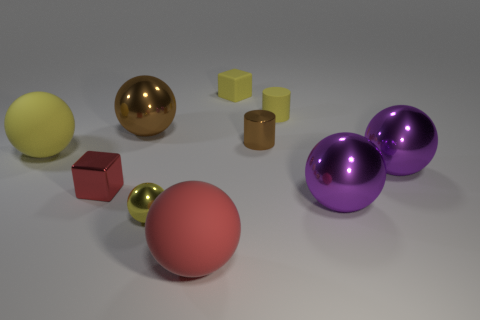Are there an equal number of purple metallic things that are left of the big red rubber thing and matte blocks?
Give a very brief answer. No. There is a matte sphere to the right of the large brown metallic sphere; what size is it?
Offer a terse response. Large. What number of yellow things are the same shape as the tiny brown metallic thing?
Provide a succinct answer. 1. What material is the big ball that is both in front of the small red metal object and right of the tiny yellow cylinder?
Offer a very short reply. Metal. Does the small ball have the same material as the brown cylinder?
Your answer should be very brief. Yes. How many large green metallic objects are there?
Offer a very short reply. 0. There is a large matte object in front of the rubber ball that is behind the red thing that is behind the yellow metallic ball; what color is it?
Make the answer very short. Red. Is the color of the metallic cube the same as the small shiny sphere?
Offer a terse response. No. What number of small objects are in front of the large yellow rubber ball and right of the large brown metal ball?
Provide a short and direct response. 1. How many matte objects are either small objects or large yellow things?
Provide a succinct answer. 3. 